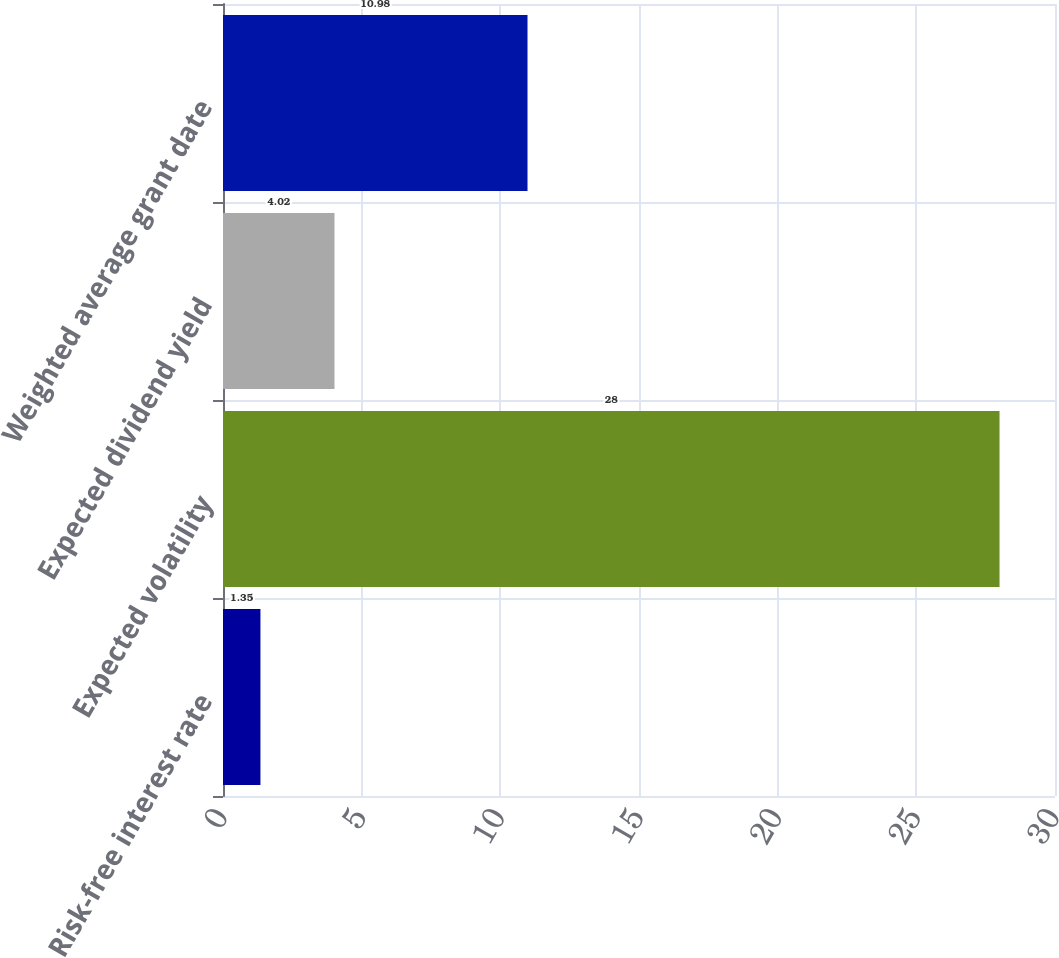Convert chart. <chart><loc_0><loc_0><loc_500><loc_500><bar_chart><fcel>Risk-free interest rate<fcel>Expected volatility<fcel>Expected dividend yield<fcel>Weighted average grant date<nl><fcel>1.35<fcel>28<fcel>4.02<fcel>10.98<nl></chart> 